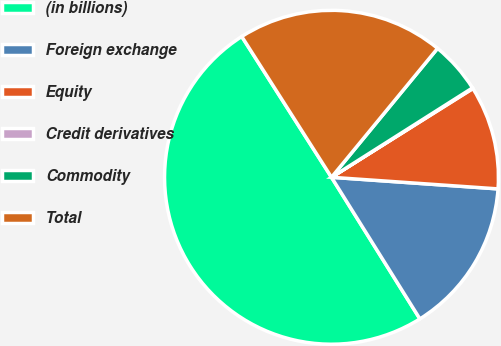Convert chart. <chart><loc_0><loc_0><loc_500><loc_500><pie_chart><fcel>(in billions)<fcel>Foreign exchange<fcel>Equity<fcel>Credit derivatives<fcel>Commodity<fcel>Total<nl><fcel>49.85%<fcel>15.01%<fcel>10.03%<fcel>0.07%<fcel>5.05%<fcel>19.99%<nl></chart> 